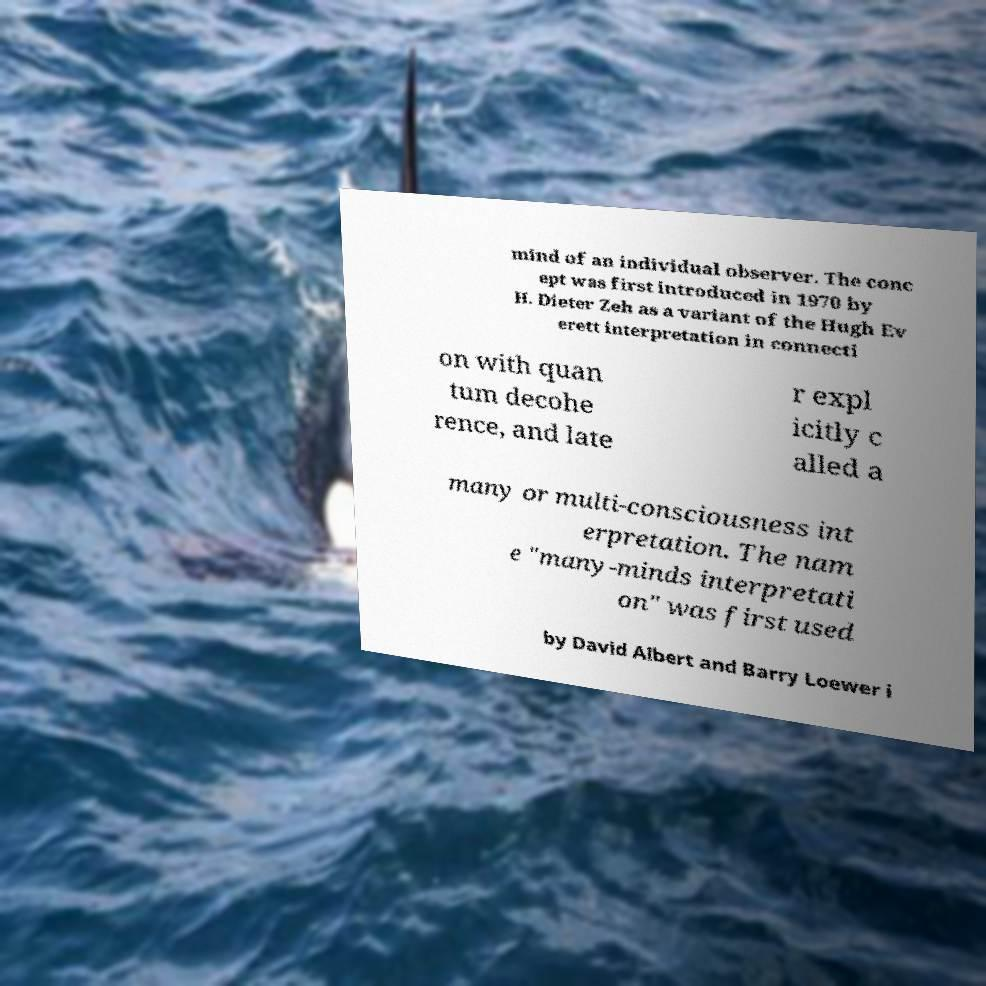For documentation purposes, I need the text within this image transcribed. Could you provide that? mind of an individual observer. The conc ept was first introduced in 1970 by H. Dieter Zeh as a variant of the Hugh Ev erett interpretation in connecti on with quan tum decohe rence, and late r expl icitly c alled a many or multi-consciousness int erpretation. The nam e "many-minds interpretati on" was first used by David Albert and Barry Loewer i 